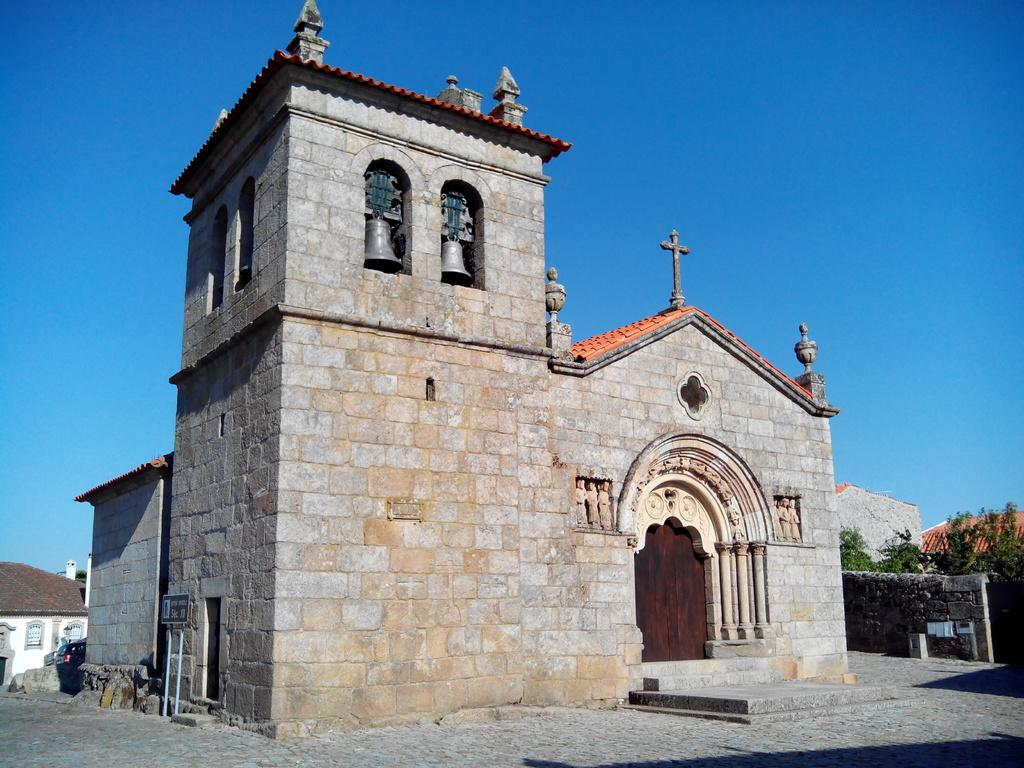What is located in the foreground of the image? There is a building and a pavement in the foreground of the image. What can be seen in the background of the image? There are houses, trees, a wall, and the sky visible in the background of the image. What type of discussion is taking place in the image? There is no discussion taking place in the image; it is a still image of a building, pavement, houses, trees, a wall, and the sky. What sound can be heard coming from the breakfast in the image? There is no breakfast present in the image, and therefore no sound can be heard from it. 